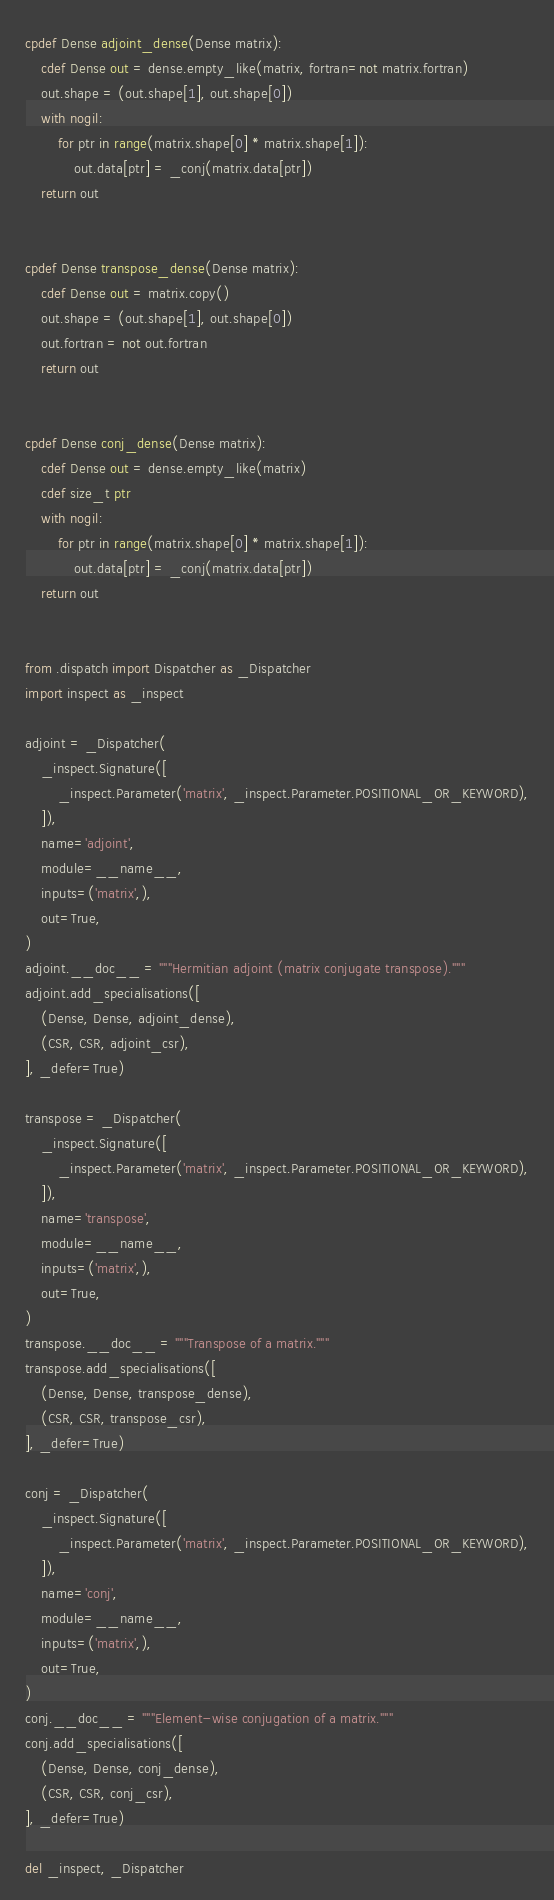Convert code to text. <code><loc_0><loc_0><loc_500><loc_500><_Cython_>cpdef Dense adjoint_dense(Dense matrix):
    cdef Dense out = dense.empty_like(matrix, fortran=not matrix.fortran)
    out.shape = (out.shape[1], out.shape[0])
    with nogil:
        for ptr in range(matrix.shape[0] * matrix.shape[1]):
            out.data[ptr] = _conj(matrix.data[ptr])
    return out


cpdef Dense transpose_dense(Dense matrix):
    cdef Dense out = matrix.copy()
    out.shape = (out.shape[1], out.shape[0])
    out.fortran = not out.fortran
    return out


cpdef Dense conj_dense(Dense matrix):
    cdef Dense out = dense.empty_like(matrix)
    cdef size_t ptr
    with nogil:
        for ptr in range(matrix.shape[0] * matrix.shape[1]):
            out.data[ptr] = _conj(matrix.data[ptr])
    return out


from .dispatch import Dispatcher as _Dispatcher
import inspect as _inspect

adjoint = _Dispatcher(
    _inspect.Signature([
        _inspect.Parameter('matrix', _inspect.Parameter.POSITIONAL_OR_KEYWORD),
    ]),
    name='adjoint',
    module=__name__,
    inputs=('matrix',),
    out=True,
)
adjoint.__doc__ = """Hermitian adjoint (matrix conjugate transpose)."""
adjoint.add_specialisations([
    (Dense, Dense, adjoint_dense),
    (CSR, CSR, adjoint_csr),
], _defer=True)

transpose = _Dispatcher(
    _inspect.Signature([
        _inspect.Parameter('matrix', _inspect.Parameter.POSITIONAL_OR_KEYWORD),
    ]),
    name='transpose',
    module=__name__,
    inputs=('matrix',),
    out=True,
)
transpose.__doc__ = """Transpose of a matrix."""
transpose.add_specialisations([
    (Dense, Dense, transpose_dense),
    (CSR, CSR, transpose_csr),
], _defer=True)

conj = _Dispatcher(
    _inspect.Signature([
        _inspect.Parameter('matrix', _inspect.Parameter.POSITIONAL_OR_KEYWORD),
    ]),
    name='conj',
    module=__name__,
    inputs=('matrix',),
    out=True,
)
conj.__doc__ = """Element-wise conjugation of a matrix."""
conj.add_specialisations([
    (Dense, Dense, conj_dense),
    (CSR, CSR, conj_csr),
], _defer=True)

del _inspect, _Dispatcher
</code> 